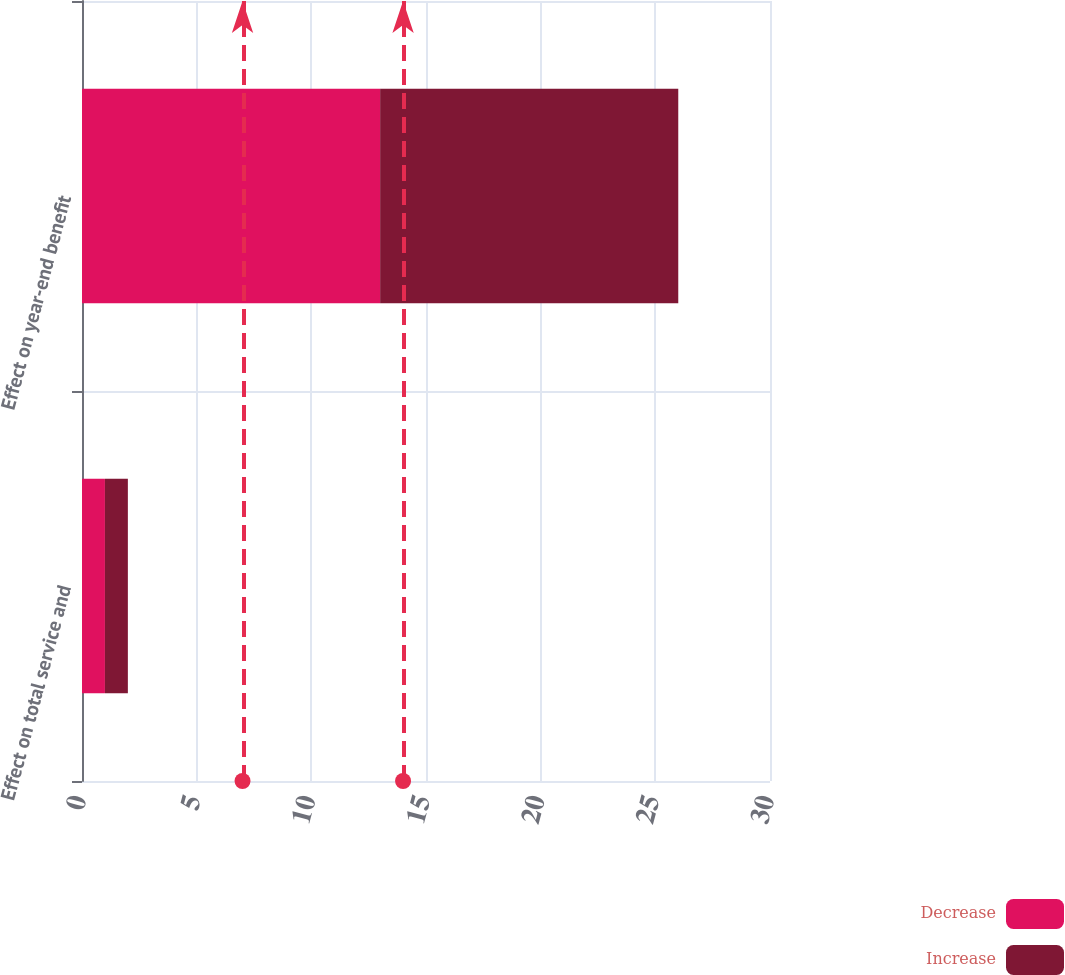<chart> <loc_0><loc_0><loc_500><loc_500><stacked_bar_chart><ecel><fcel>Effect on total service and<fcel>Effect on year-end benefit<nl><fcel>Decrease<fcel>1<fcel>13<nl><fcel>Increase<fcel>1<fcel>13<nl></chart> 